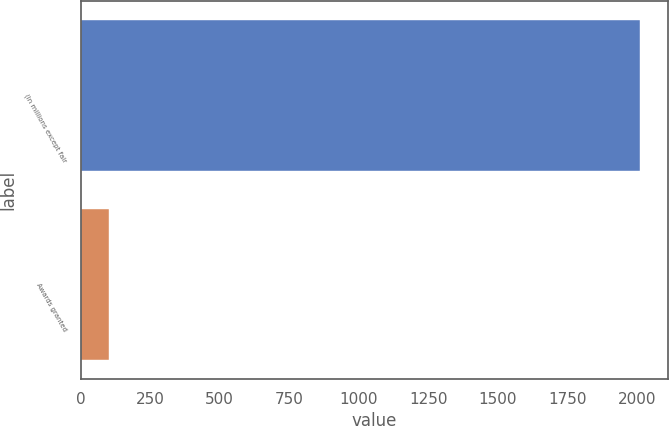Convert chart. <chart><loc_0><loc_0><loc_500><loc_500><bar_chart><fcel>(In millions except fair<fcel>Awards granted<nl><fcel>2013<fcel>104<nl></chart> 